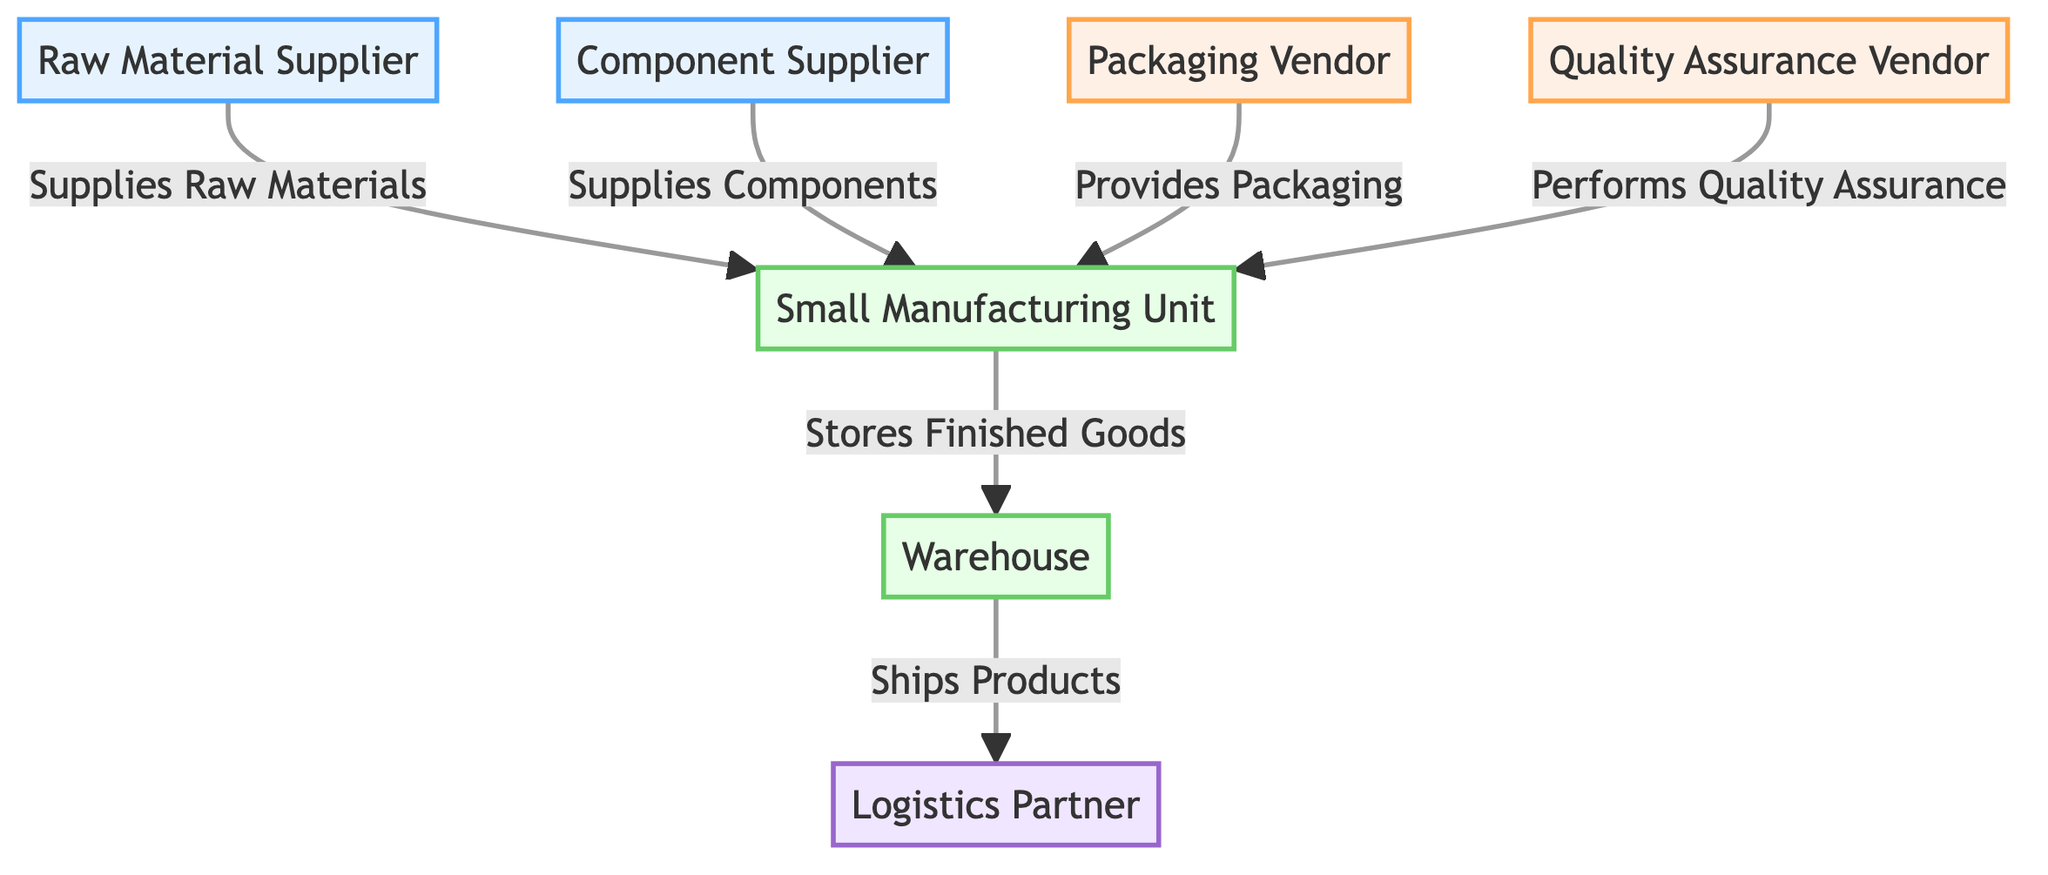What types of suppliers are shown in the diagram? The diagram shows two types of suppliers: a Raw Material Supplier and a Component Supplier. These are represented by two distinct nodes labeled accordingly.
Answer: Raw Material Supplier, Component Supplier How many vendors are represented in the diagram? The diagram features two vendors, each providing different services to the manufacturing unit. This is determined by counting the vendor nodes within the diagram.
Answer: 2 What does the Packaging Vendor provide? According to the diagram, the Packaging Vendor is labeled to provide packaging materials and services, which is indicated by the directed edge leading to the manufacturing unit.
Answer: Provides Packaging From which node do the raw materials originate? The origin of raw materials in the diagram is indicated by the edge connecting the Raw Material Supplier to the Small Manufacturing Unit, showing the flow of materials into production.
Answer: Raw Material Supplier Which entity performs quality assurance? The diagram identifies the Quality Assurance Vendor as the entity responsible for quality assurance services, essentially indicated by the directed edge connecting this vendor to the manufacturing unit.
Answer: Quality Assurance Vendor What role does the warehouse play in the network? The warehouse serves as a storage location in the network, with an edge illustrating its relationship to the manufacturing unit where it stores finished goods.
Answer: Stores Finished Goods How do finished products reach logistics? Finished products reach logistics via the edge from the warehouse to logistics, indicating that products are shipped from the warehouse to the logistics partner for distribution.
Answer: Ships Products What is the total number of nodes in the diagram? The total number of nodes is calculated by counting each distinct entity represented, which includes suppliers, vendors, and functional units. There are seven nodes in total.
Answer: 7 What is the type of the Small Manufacturing Unit node? The Small Manufacturing Unit is classified as a main entity in the network, distinguished by its green fill color and the role it plays in assembling raw materials and components.
Answer: main 